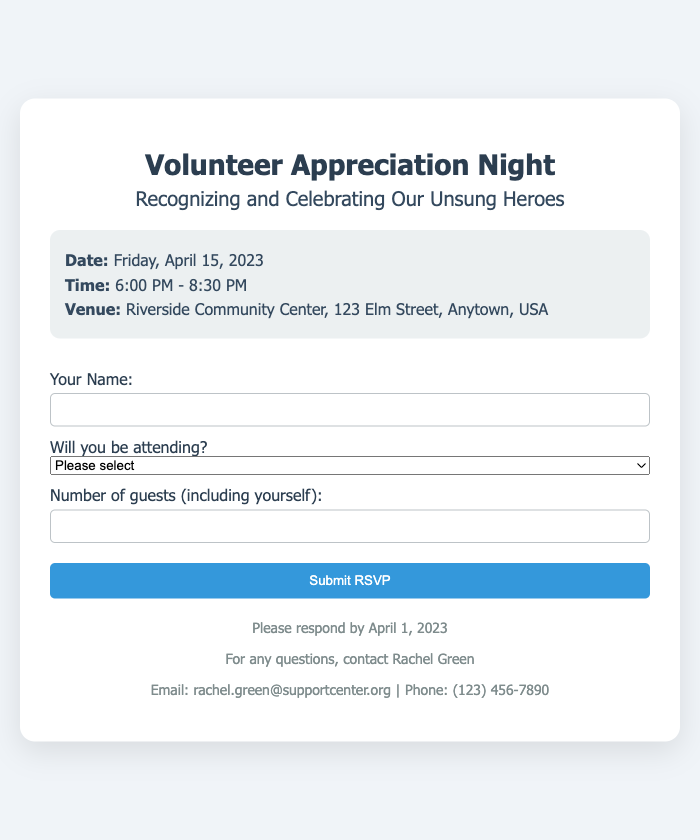What is the date of the event? The date of the event is mentioned clearly in the document as "Friday, April 15, 2023."
Answer: Friday, April 15, 2023 What time does the event start? The event's starting time is provided as "6:00 PM" in the schedule section of the document.
Answer: 6:00 PM Where is the venue located? The venue name and address are specified in the document as "Riverside Community Center, 123 Elm Street, Anytown, USA."
Answer: Riverside Community Center, 123 Elm Street, Anytown, USA What is the latest date to respond? The document states that responses should be made by "April 1, 2023."
Answer: April 1, 2023 Who should I contact for questions? The contact person for inquiries is identified in the document as "Rachel Green."
Answer: Rachel Green What is the maximum number of guests allowed? The RSVP form indicates a limit of "5" as the maximum number of guests including oneself.
Answer: 5 What type of event is this? The document clearly indicates this is a "Volunteer Appreciation Night."
Answer: Volunteer Appreciation Night What activities are highlighted in the event description? The document mentions "recognition activities and networking opportunities" as key aspects of the event.
Answer: recognition activities and networking opportunities 